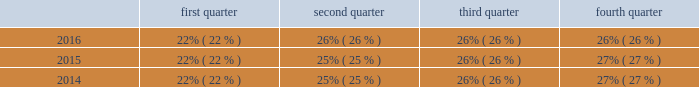Seasonality our business experiences seasonality that varies by product line .
Because more construction and do-it-yourself projects occur during the second and third calendar quarters of each year in the northern hemisphere , our security product sales , typically , are higher in those quarters than in the first and fourth calendar quarters .
However , our interflex business typically experiences higher sales in the fourth calendar quarter due to project timing .
Revenue by quarter for the years ended december 31 , 2016 , 2015 and 2014 are as follows: .
Employees as of december 31 , 2016 , we had more than 9400 employees .
Environmental regulation we have a dedicated environmental program that is designed to reduce the utilization and generation of hazardous materials during the manufacturing process as well as to remediate identified environmental concerns .
As to the latter , we are currently engaged in site investigations and remediation activities to address environmental cleanup from past operations at current and former production facilities .
The company regularly evaluates its remediation programs and considers alternative remediation methods that are in addition to , or in replacement of , those currently utilized by the company based upon enhanced technology and regulatory changes .
We are sometimes a party to environmental lawsuits and claims and have received notices of potential violations of environmental laws and regulations from the u.s .
Environmental protection agency ( the "epa" ) and similar state authorities .
We have also been identified as a potentially responsible party ( "prp" ) for cleanup costs associated with off-site waste disposal at federal superfund and state remediation sites .
For all such sites , there are other prps and , in most instances , our involvement is minimal .
In estimating our liability , we have assumed that we will not bear the entire cost of remediation of any site to the exclusion of other prps who may be jointly and severally liable .
The ability of other prps to participate has been taken into account , based on our understanding of the parties 2019 financial condition and probable contributions on a per site basis .
Additional lawsuits and claims involving environmental matters are likely to arise from time to time in the future .
We incurred $ 23.3 million , $ 4.4 million , and $ 2.9 million of expenses during the years ended december 31 , 2016 , 2015 , and 2014 , respectively , for environmental remediation at sites presently or formerly owned or leased by us .
As of december 31 , 2016 and 2015 , we have recorded reserves for environmental matters of $ 30.6 million and $ 15.2 million .
Of these amounts $ 9.6 million and $ 2.8 million , respectively , relate to remediation of sites previously disposed by us .
Given the evolving nature of environmental laws , regulations and technology , the ultimate cost of future compliance is uncertain .
Available information we are required to file annual , quarterly , and current reports , proxy statements , and other documents with the u.s .
Securities and exchange commission ( "sec" ) .
The public may read and copy any materials filed with the sec at the sec 2019s public reference room at 100 f street , n.e. , washington , d.c .
20549 .
The public may obtain information on the operation of the public reference room by calling the sec at 1-800-sec-0330 .
Also , the sec maintains an internet website that contains reports , proxy and information statements , and other information regarding issuers that file electronically with the sec .
The public can obtain any documents that are filed by us at http://www.sec.gov .
In addition , this annual report on form 10-k , as well as future quarterly reports on form 10-q , current reports on form 8-k and any amendments to all of the foregoing reports , are made available free of charge on our internet website ( http://www.allegion.com ) as soon as reasonably practicable after such reports are electronically filed with or furnished to the sec .
The contents of our website are not incorporated by reference in this report. .
Considering the year 2015 , what is the highest revenue? 
Rationale: it is the maximum value of revenue for that year .
Computations: table_max(2015, none)
Answer: 0.27. 